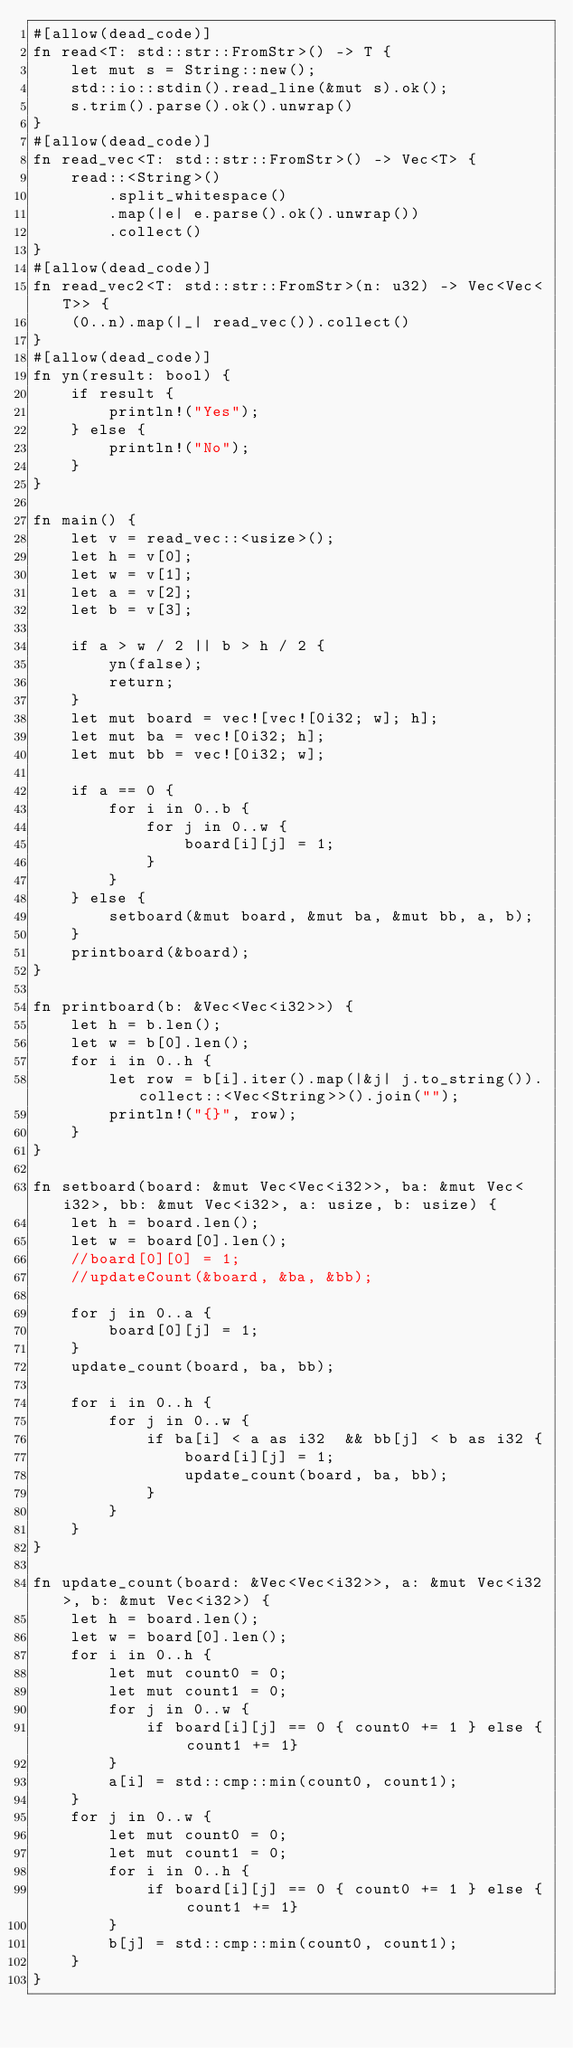Convert code to text. <code><loc_0><loc_0><loc_500><loc_500><_Rust_>#[allow(dead_code)]
fn read<T: std::str::FromStr>() -> T {
    let mut s = String::new();
    std::io::stdin().read_line(&mut s).ok();
    s.trim().parse().ok().unwrap()
}
#[allow(dead_code)]
fn read_vec<T: std::str::FromStr>() -> Vec<T> {
    read::<String>()
        .split_whitespace()
        .map(|e| e.parse().ok().unwrap())
        .collect()
}
#[allow(dead_code)]
fn read_vec2<T: std::str::FromStr>(n: u32) -> Vec<Vec<T>> {
    (0..n).map(|_| read_vec()).collect()
}
#[allow(dead_code)]
fn yn(result: bool) {
    if result {
        println!("Yes");
    } else {
        println!("No");
    }
}

fn main() {
    let v = read_vec::<usize>();
    let h = v[0];
    let w = v[1];
    let a = v[2];
    let b = v[3];

    if a > w / 2 || b > h / 2 {
        yn(false);
        return;
    }
    let mut board = vec![vec![0i32; w]; h];
    let mut ba = vec![0i32; h];
    let mut bb = vec![0i32; w];

    if a == 0 {
        for i in 0..b {
            for j in 0..w {
                board[i][j] = 1;
            }
        }
    } else {
        setboard(&mut board, &mut ba, &mut bb, a, b);
    }
    printboard(&board);
}

fn printboard(b: &Vec<Vec<i32>>) {
    let h = b.len();
    let w = b[0].len();
    for i in 0..h {
        let row = b[i].iter().map(|&j| j.to_string()).collect::<Vec<String>>().join("");
        println!("{}", row);
    }
}

fn setboard(board: &mut Vec<Vec<i32>>, ba: &mut Vec<i32>, bb: &mut Vec<i32>, a: usize, b: usize) {
    let h = board.len();
    let w = board[0].len();
    //board[0][0] = 1;
    //updateCount(&board, &ba, &bb);

    for j in 0..a {
        board[0][j] = 1;
    }
    update_count(board, ba, bb);

    for i in 0..h {
        for j in 0..w {
            if ba[i] < a as i32  && bb[j] < b as i32 {
                board[i][j] = 1;
                update_count(board, ba, bb);
            }
        }
    }
}

fn update_count(board: &Vec<Vec<i32>>, a: &mut Vec<i32>, b: &mut Vec<i32>) {
    let h = board.len();
    let w = board[0].len();
    for i in 0..h {
        let mut count0 = 0;
        let mut count1 = 0;
        for j in 0..w {
            if board[i][j] == 0 { count0 += 1 } else { count1 += 1}
        }
        a[i] = std::cmp::min(count0, count1);
    }
    for j in 0..w {
        let mut count0 = 0;
        let mut count1 = 0;
        for i in 0..h {
            if board[i][j] == 0 { count0 += 1 } else { count1 += 1}
        }
        b[j] = std::cmp::min(count0, count1);
    }
}

</code> 